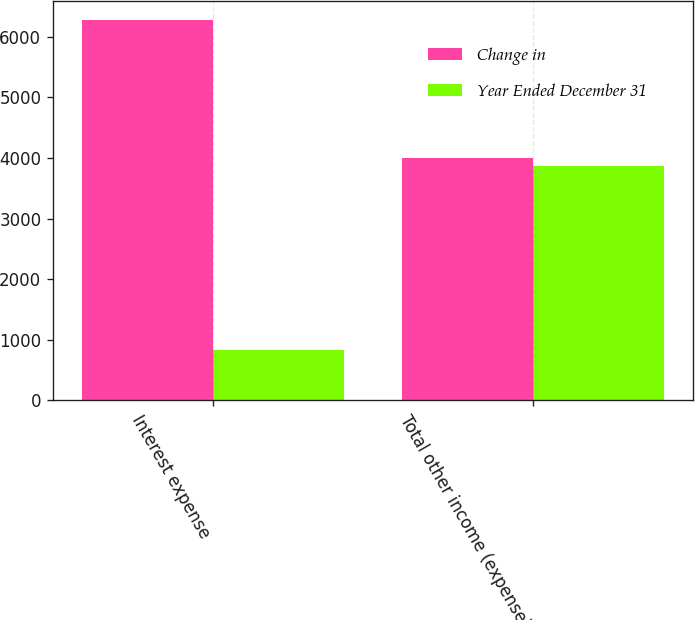Convert chart. <chart><loc_0><loc_0><loc_500><loc_500><stacked_bar_chart><ecel><fcel>Interest expense<fcel>Total other income (expense)<nl><fcel>Change in<fcel>6280<fcel>4005<nl><fcel>Year Ended December 31<fcel>839<fcel>3868<nl></chart> 